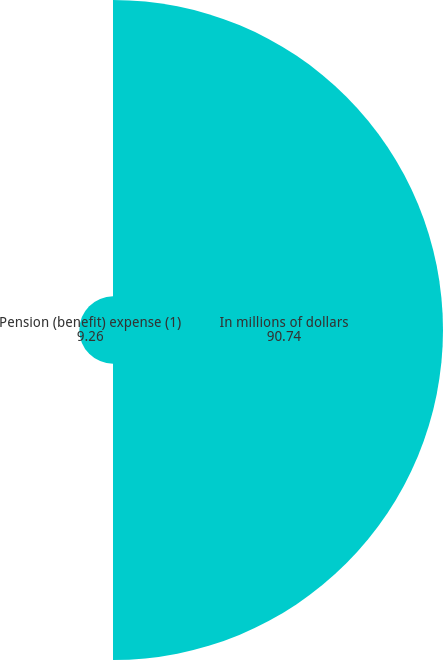Convert chart to OTSL. <chart><loc_0><loc_0><loc_500><loc_500><pie_chart><fcel>In millions of dollars<fcel>Pension (benefit) expense (1)<nl><fcel>90.74%<fcel>9.26%<nl></chart> 